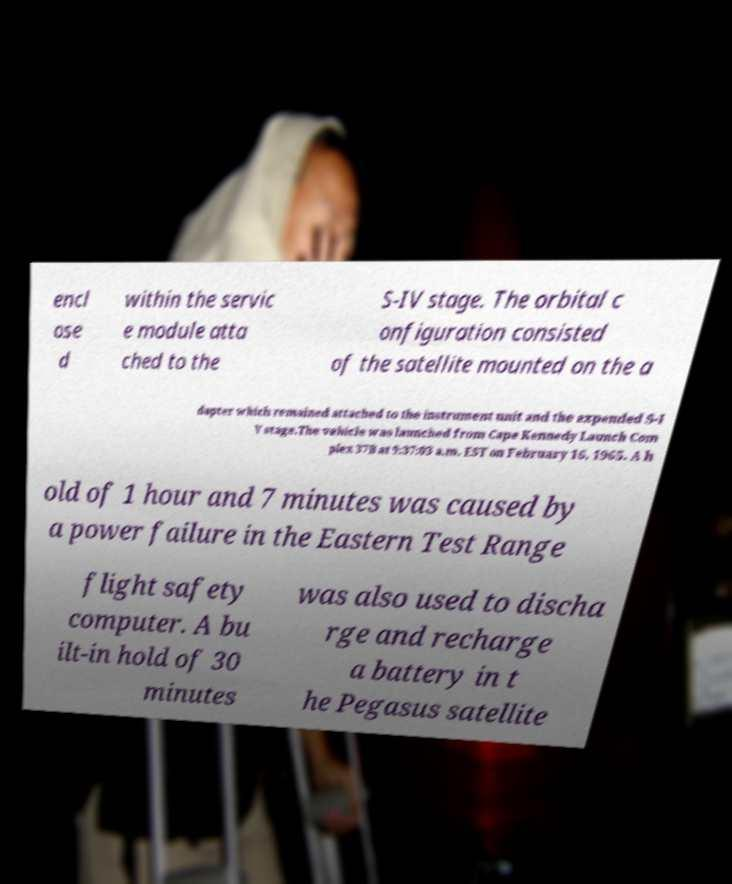I need the written content from this picture converted into text. Can you do that? encl ose d within the servic e module atta ched to the S-IV stage. The orbital c onfiguration consisted of the satellite mounted on the a dapter which remained attached to the instrument unit and the expended S-I V stage.The vehicle was launched from Cape Kennedy Launch Com plex 37B at 9:37:03 a.m. EST on February 16, 1965. A h old of 1 hour and 7 minutes was caused by a power failure in the Eastern Test Range flight safety computer. A bu ilt-in hold of 30 minutes was also used to discha rge and recharge a battery in t he Pegasus satellite 